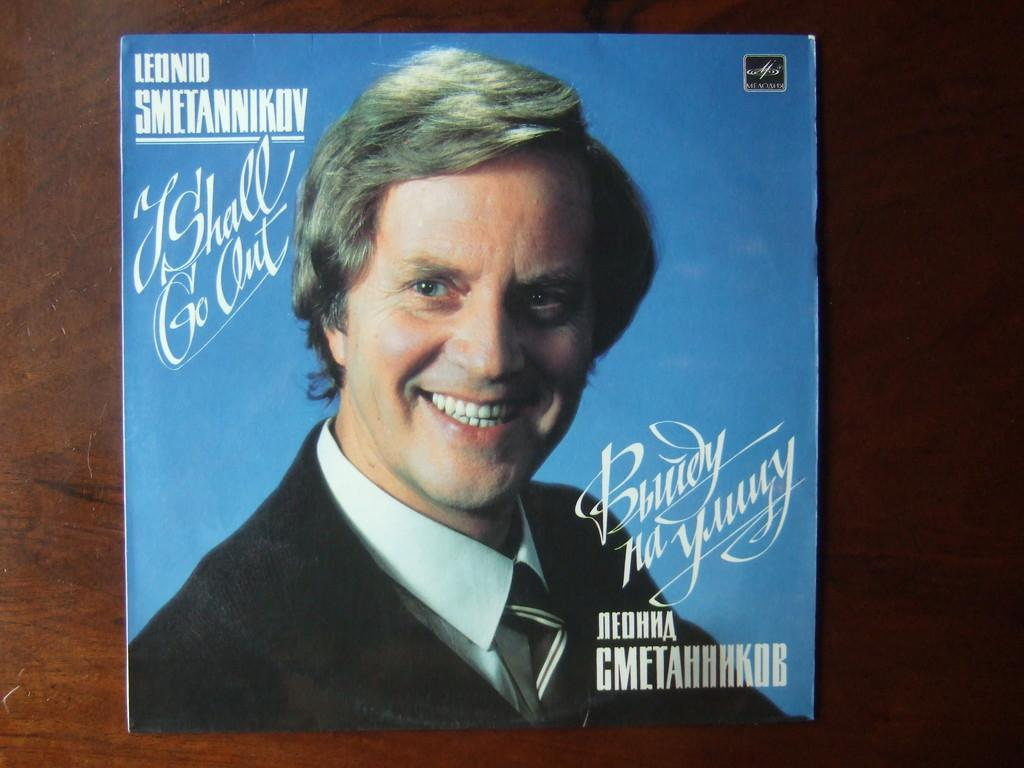What type of surface is visible in the image? There is a wooden surface in the image. What is placed on the wooden surface? There is a poster on the wooden surface. What is depicted in the poster? The poster contains a picture of a man smiling. What is the man in the poster wearing? The man in the poster is wearing clothes. What else can be found on the poster besides the picture? There is text in the poster. What type of battle is taking place in the image? There is no battle present in the image; it features a poster with a picture of a smiling man. Can you tell me how many squirrels are visible in the image? There are no squirrels visible in the image. 